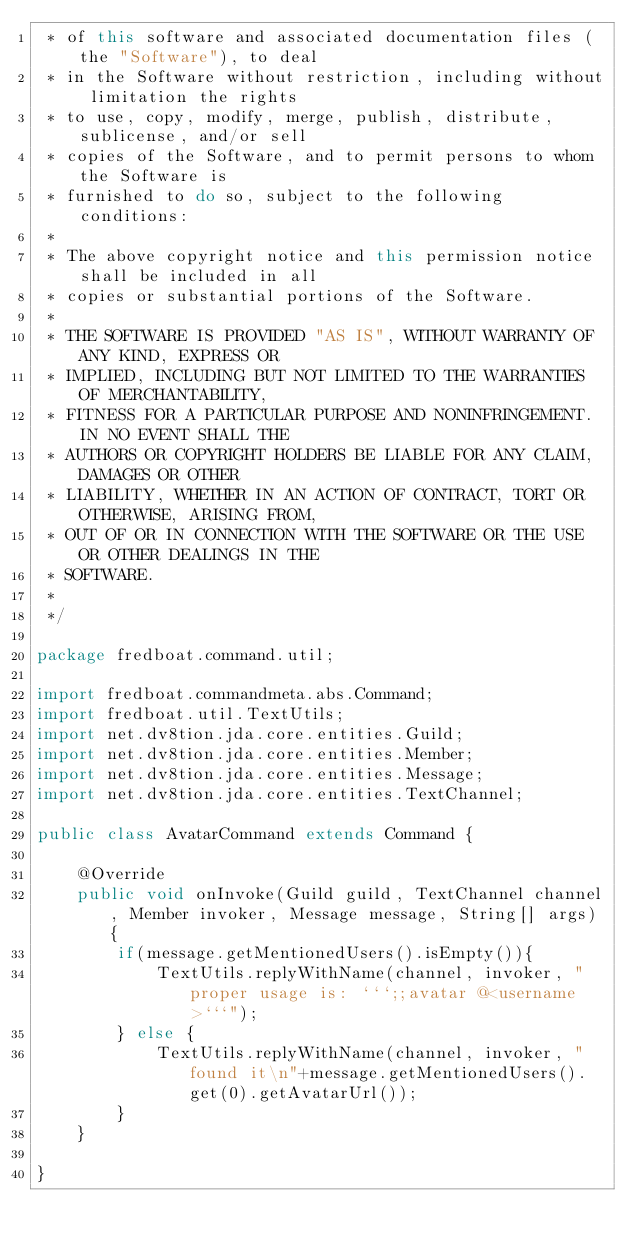Convert code to text. <code><loc_0><loc_0><loc_500><loc_500><_Java_> * of this software and associated documentation files (the "Software"), to deal
 * in the Software without restriction, including without limitation the rights
 * to use, copy, modify, merge, publish, distribute, sublicense, and/or sell
 * copies of the Software, and to permit persons to whom the Software is
 * furnished to do so, subject to the following conditions:
 *
 * The above copyright notice and this permission notice shall be included in all
 * copies or substantial portions of the Software.
 *
 * THE SOFTWARE IS PROVIDED "AS IS", WITHOUT WARRANTY OF ANY KIND, EXPRESS OR
 * IMPLIED, INCLUDING BUT NOT LIMITED TO THE WARRANTIES OF MERCHANTABILITY,
 * FITNESS FOR A PARTICULAR PURPOSE AND NONINFRINGEMENT. IN NO EVENT SHALL THE
 * AUTHORS OR COPYRIGHT HOLDERS BE LIABLE FOR ANY CLAIM, DAMAGES OR OTHER
 * LIABILITY, WHETHER IN AN ACTION OF CONTRACT, TORT OR OTHERWISE, ARISING FROM,
 * OUT OF OR IN CONNECTION WITH THE SOFTWARE OR THE USE OR OTHER DEALINGS IN THE
 * SOFTWARE.
 *
 */

package fredboat.command.util;

import fredboat.commandmeta.abs.Command;
import fredboat.util.TextUtils;
import net.dv8tion.jda.core.entities.Guild;
import net.dv8tion.jda.core.entities.Member;
import net.dv8tion.jda.core.entities.Message;
import net.dv8tion.jda.core.entities.TextChannel;

public class AvatarCommand extends Command {

    @Override
    public void onInvoke(Guild guild, TextChannel channel, Member invoker, Message message, String[] args) {
        if(message.getMentionedUsers().isEmpty()){
            TextUtils.replyWithName(channel, invoker, " proper usage is: ```;;avatar @<username>```");
        } else {
            TextUtils.replyWithName(channel, invoker, " found it\n"+message.getMentionedUsers().get(0).getAvatarUrl());
        }
    }

}
</code> 